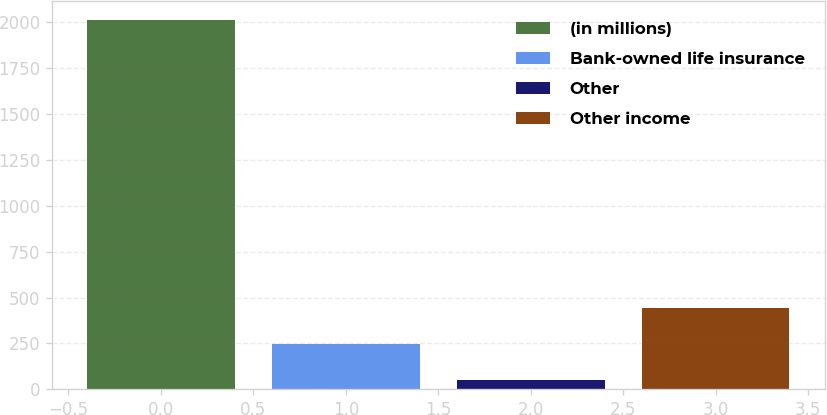Convert chart to OTSL. <chart><loc_0><loc_0><loc_500><loc_500><bar_chart><fcel>(in millions)<fcel>Bank-owned life insurance<fcel>Other<fcel>Other income<nl><fcel>2015<fcel>246.5<fcel>50<fcel>443<nl></chart> 